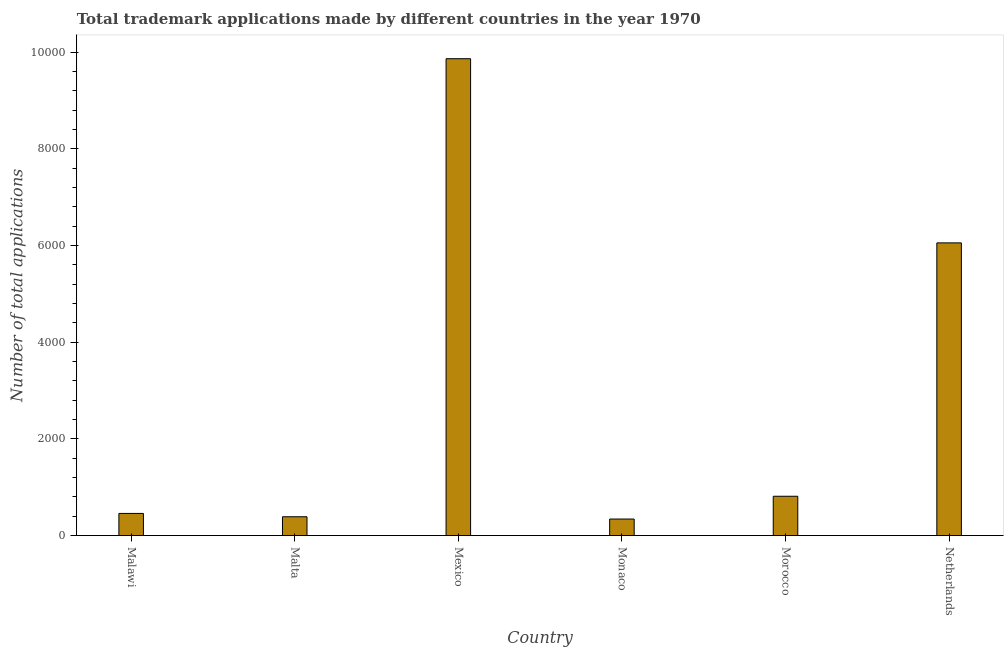What is the title of the graph?
Make the answer very short. Total trademark applications made by different countries in the year 1970. What is the label or title of the Y-axis?
Your answer should be compact. Number of total applications. What is the number of trademark applications in Netherlands?
Offer a terse response. 6055. Across all countries, what is the maximum number of trademark applications?
Give a very brief answer. 9865. Across all countries, what is the minimum number of trademark applications?
Provide a short and direct response. 342. In which country was the number of trademark applications minimum?
Make the answer very short. Monaco. What is the sum of the number of trademark applications?
Provide a short and direct response. 1.79e+04. What is the difference between the number of trademark applications in Malawi and Netherlands?
Offer a terse response. -5597. What is the average number of trademark applications per country?
Offer a terse response. 2987. What is the median number of trademark applications?
Keep it short and to the point. 635.5. In how many countries, is the number of trademark applications greater than 4800 ?
Your answer should be very brief. 2. What is the ratio of the number of trademark applications in Malawi to that in Morocco?
Offer a terse response. 0.56. Is the number of trademark applications in Malawi less than that in Monaco?
Provide a succinct answer. No. Is the difference between the number of trademark applications in Malta and Mexico greater than the difference between any two countries?
Your answer should be compact. No. What is the difference between the highest and the second highest number of trademark applications?
Your answer should be very brief. 3810. What is the difference between the highest and the lowest number of trademark applications?
Your answer should be very brief. 9523. How many bars are there?
Give a very brief answer. 6. How many countries are there in the graph?
Keep it short and to the point. 6. Are the values on the major ticks of Y-axis written in scientific E-notation?
Your answer should be very brief. No. What is the Number of total applications of Malawi?
Make the answer very short. 458. What is the Number of total applications in Malta?
Provide a succinct answer. 389. What is the Number of total applications of Mexico?
Your answer should be compact. 9865. What is the Number of total applications in Monaco?
Ensure brevity in your answer.  342. What is the Number of total applications in Morocco?
Ensure brevity in your answer.  813. What is the Number of total applications of Netherlands?
Offer a very short reply. 6055. What is the difference between the Number of total applications in Malawi and Mexico?
Offer a very short reply. -9407. What is the difference between the Number of total applications in Malawi and Monaco?
Offer a very short reply. 116. What is the difference between the Number of total applications in Malawi and Morocco?
Make the answer very short. -355. What is the difference between the Number of total applications in Malawi and Netherlands?
Give a very brief answer. -5597. What is the difference between the Number of total applications in Malta and Mexico?
Keep it short and to the point. -9476. What is the difference between the Number of total applications in Malta and Monaco?
Your response must be concise. 47. What is the difference between the Number of total applications in Malta and Morocco?
Make the answer very short. -424. What is the difference between the Number of total applications in Malta and Netherlands?
Offer a terse response. -5666. What is the difference between the Number of total applications in Mexico and Monaco?
Your answer should be compact. 9523. What is the difference between the Number of total applications in Mexico and Morocco?
Offer a very short reply. 9052. What is the difference between the Number of total applications in Mexico and Netherlands?
Give a very brief answer. 3810. What is the difference between the Number of total applications in Monaco and Morocco?
Your response must be concise. -471. What is the difference between the Number of total applications in Monaco and Netherlands?
Offer a terse response. -5713. What is the difference between the Number of total applications in Morocco and Netherlands?
Give a very brief answer. -5242. What is the ratio of the Number of total applications in Malawi to that in Malta?
Your answer should be very brief. 1.18. What is the ratio of the Number of total applications in Malawi to that in Mexico?
Ensure brevity in your answer.  0.05. What is the ratio of the Number of total applications in Malawi to that in Monaco?
Keep it short and to the point. 1.34. What is the ratio of the Number of total applications in Malawi to that in Morocco?
Your response must be concise. 0.56. What is the ratio of the Number of total applications in Malawi to that in Netherlands?
Keep it short and to the point. 0.08. What is the ratio of the Number of total applications in Malta to that in Mexico?
Your response must be concise. 0.04. What is the ratio of the Number of total applications in Malta to that in Monaco?
Ensure brevity in your answer.  1.14. What is the ratio of the Number of total applications in Malta to that in Morocco?
Provide a short and direct response. 0.48. What is the ratio of the Number of total applications in Malta to that in Netherlands?
Provide a succinct answer. 0.06. What is the ratio of the Number of total applications in Mexico to that in Monaco?
Offer a very short reply. 28.84. What is the ratio of the Number of total applications in Mexico to that in Morocco?
Make the answer very short. 12.13. What is the ratio of the Number of total applications in Mexico to that in Netherlands?
Offer a very short reply. 1.63. What is the ratio of the Number of total applications in Monaco to that in Morocco?
Keep it short and to the point. 0.42. What is the ratio of the Number of total applications in Monaco to that in Netherlands?
Your answer should be compact. 0.06. What is the ratio of the Number of total applications in Morocco to that in Netherlands?
Provide a short and direct response. 0.13. 